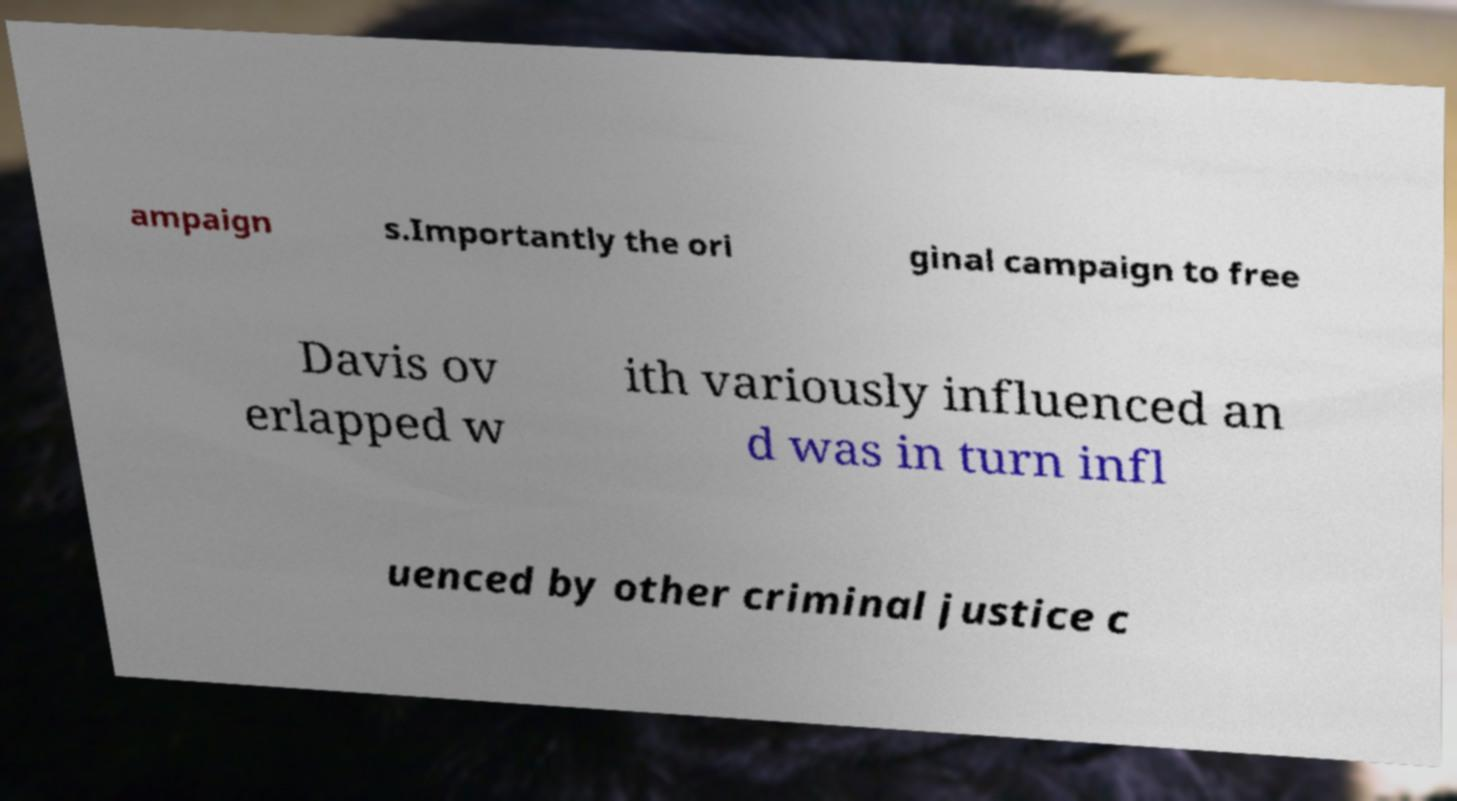Could you assist in decoding the text presented in this image and type it out clearly? ampaign s.Importantly the ori ginal campaign to free Davis ov erlapped w ith variously influenced an d was in turn infl uenced by other criminal justice c 